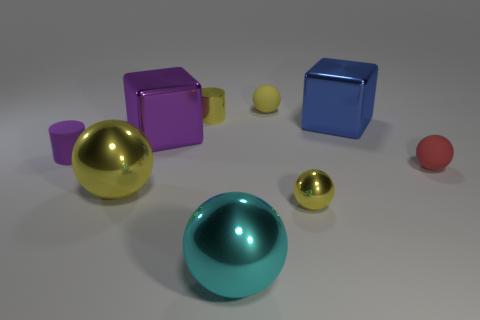If the light source were coming from the top left corner, which objects would cast the longest shadow? Given that hypothetical light source position, the objects with the most height relative to their base will cast the longest shadows. Therefore, the cylinders, particularly the yellow one closest to the left, would likely cast the longest shadows. 